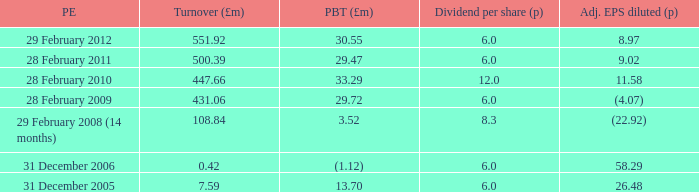What was the profit before tax when the turnover was 431.06? 29.72. 